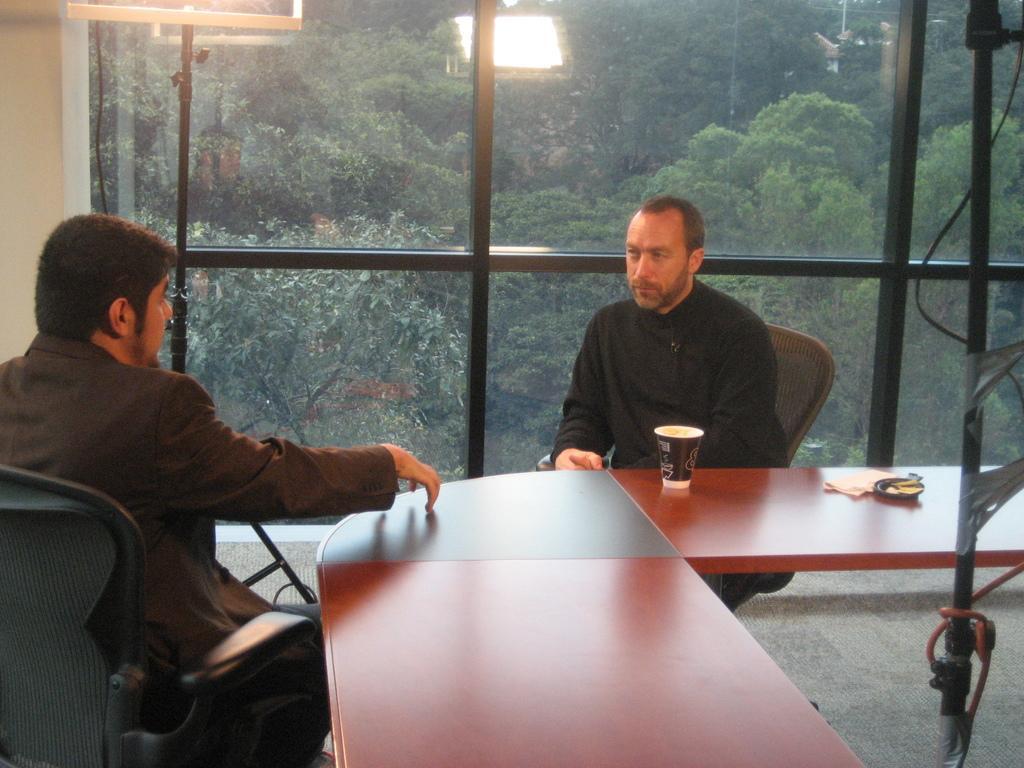Can you describe this image briefly? This is an inside view. Here I can see two men are sitting on the chairs and looking at each other. On the right side there is a table on which a paper and a glass are placed. At the back of these people there is a glass through which we can see the outside view. In outside I can see many trees. Beside the glass there is a pole. 